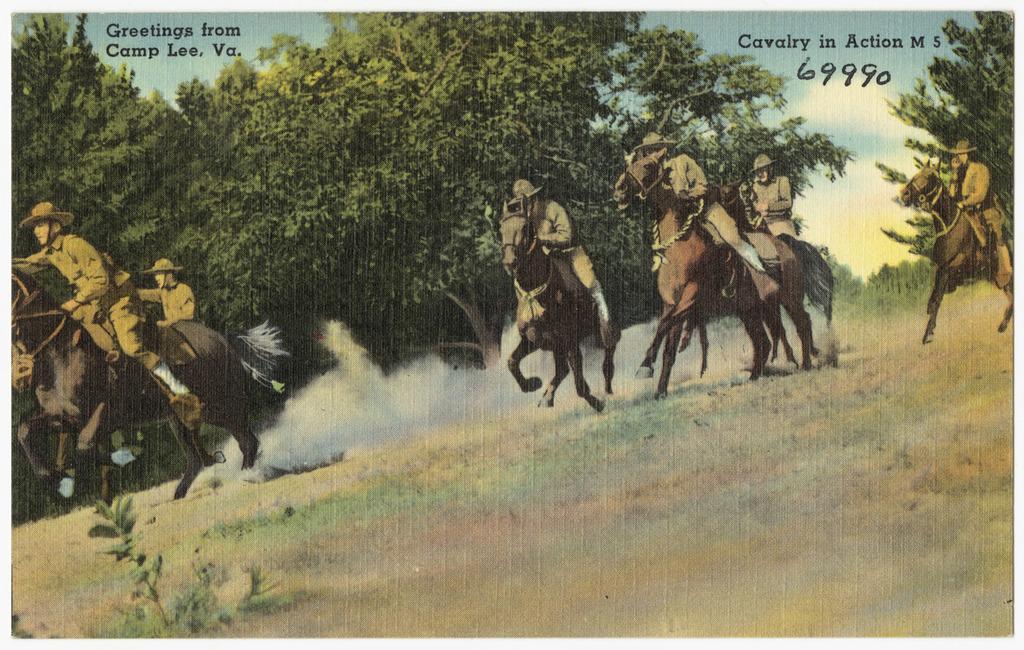In one or two sentences, can you explain what this image depicts? This picture contains a poster where we can see, people riding on the horses, greenery, sky and text. 